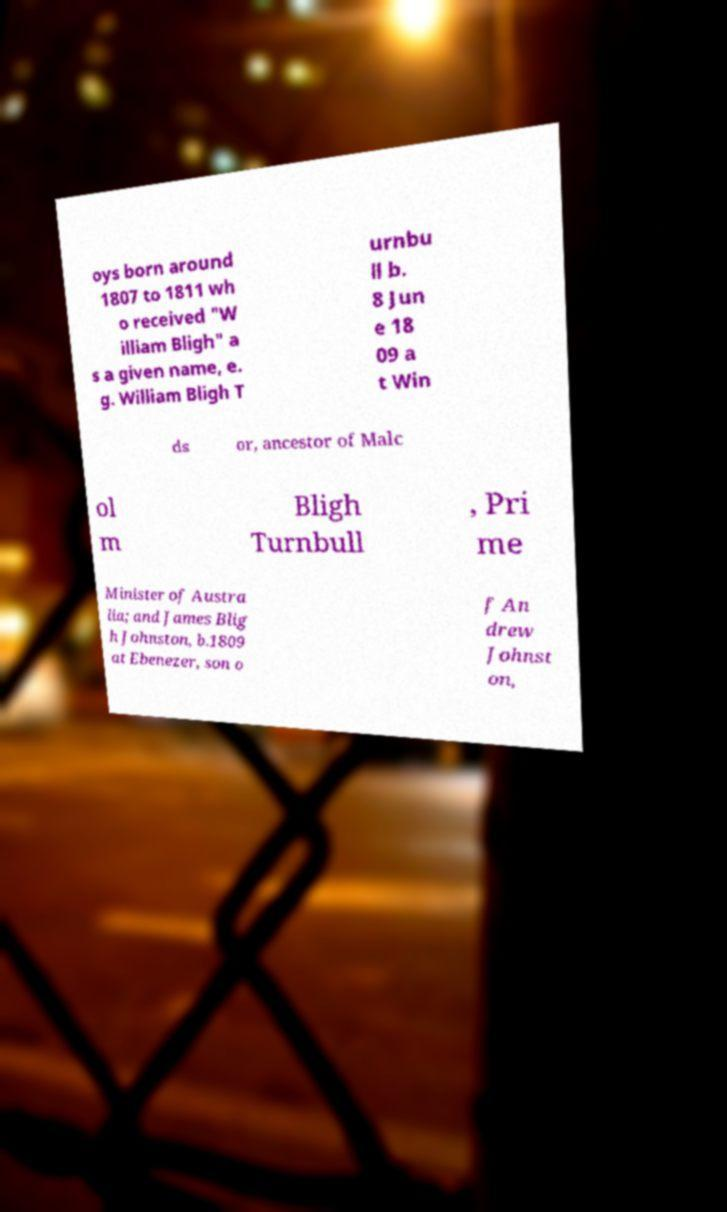What messages or text are displayed in this image? I need them in a readable, typed format. oys born around 1807 to 1811 wh o received "W illiam Bligh" a s a given name, e. g. William Bligh T urnbu ll b. 8 Jun e 18 09 a t Win ds or, ancestor of Malc ol m Bligh Turnbull , Pri me Minister of Austra lia; and James Blig h Johnston, b.1809 at Ebenezer, son o f An drew Johnst on, 